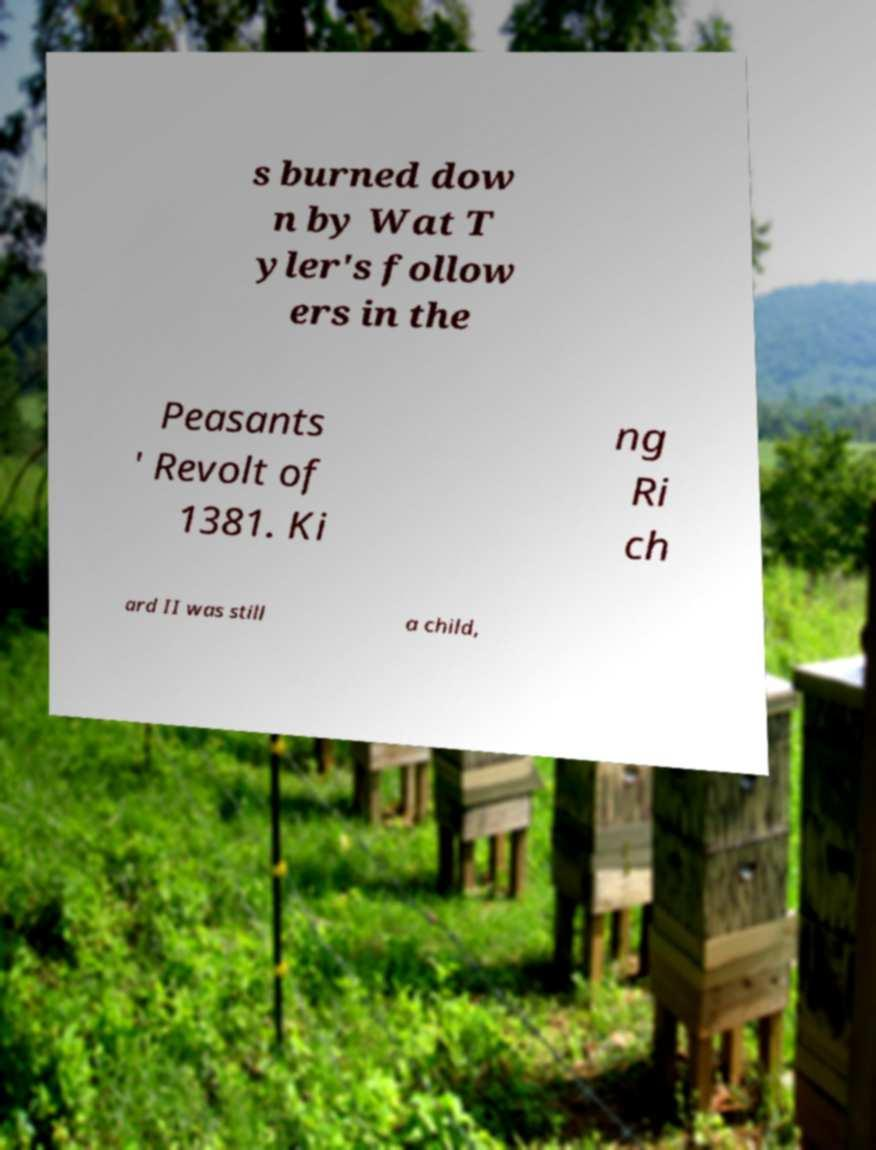There's text embedded in this image that I need extracted. Can you transcribe it verbatim? s burned dow n by Wat T yler's follow ers in the Peasants ' Revolt of 1381. Ki ng Ri ch ard II was still a child, 